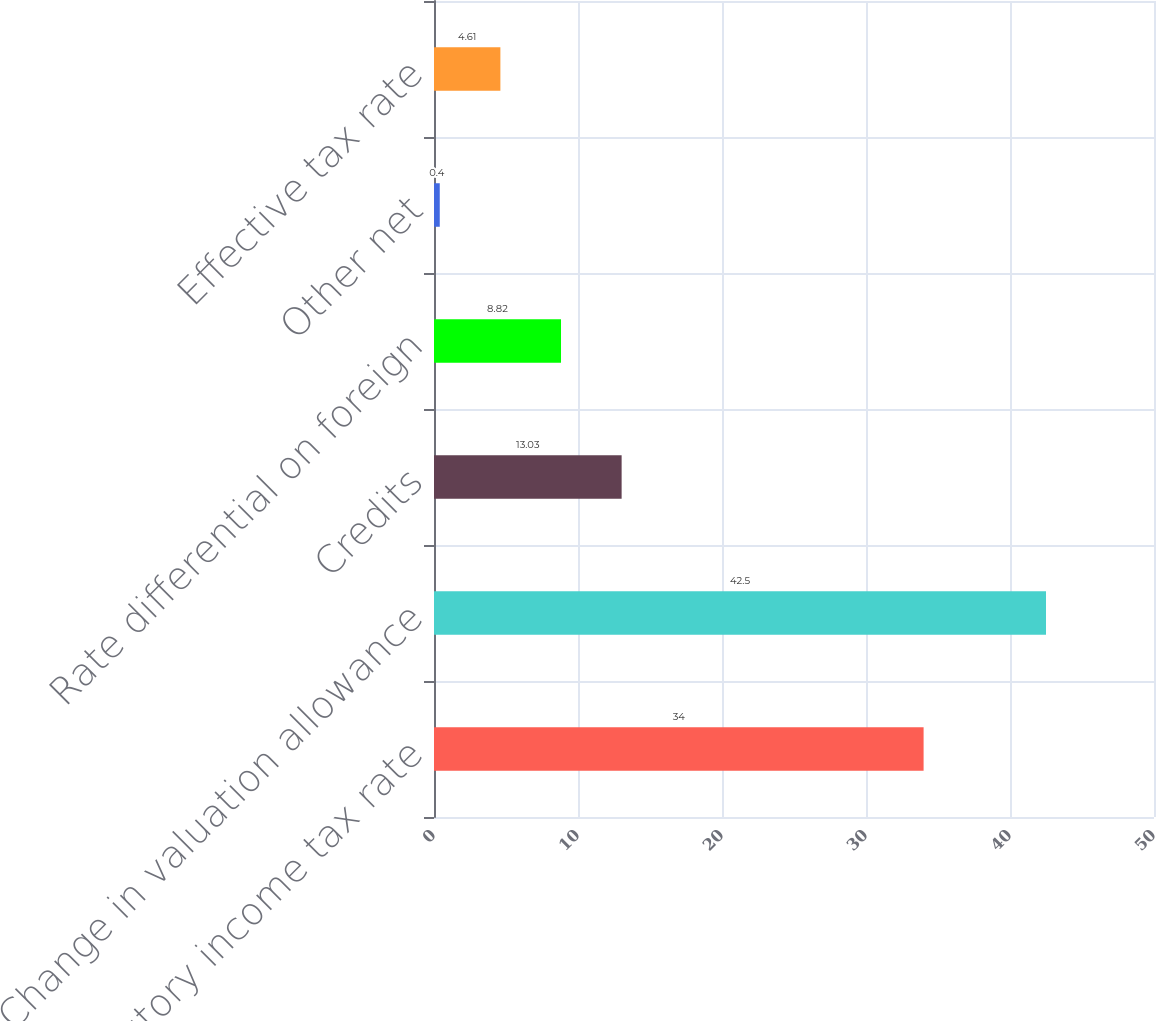Convert chart to OTSL. <chart><loc_0><loc_0><loc_500><loc_500><bar_chart><fcel>Statutory income tax rate<fcel>Change in valuation allowance<fcel>Credits<fcel>Rate differential on foreign<fcel>Other net<fcel>Effective tax rate<nl><fcel>34<fcel>42.5<fcel>13.03<fcel>8.82<fcel>0.4<fcel>4.61<nl></chart> 